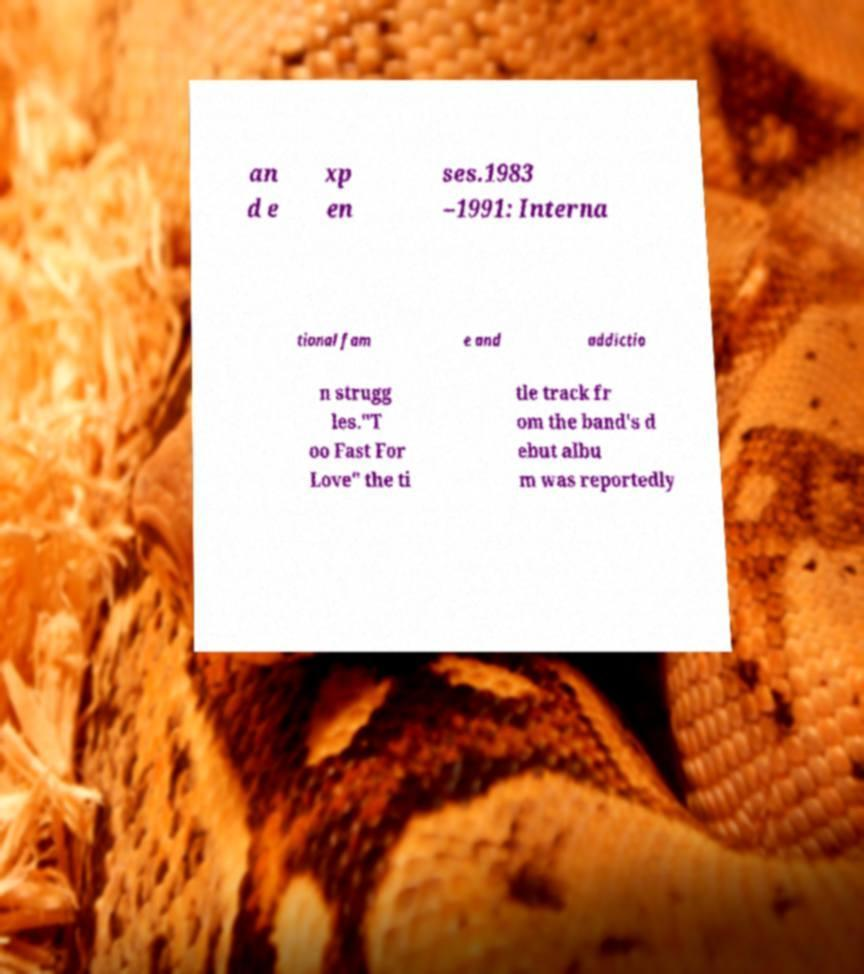I need the written content from this picture converted into text. Can you do that? an d e xp en ses.1983 –1991: Interna tional fam e and addictio n strugg les."T oo Fast For Love" the ti tle track fr om the band's d ebut albu m was reportedly 